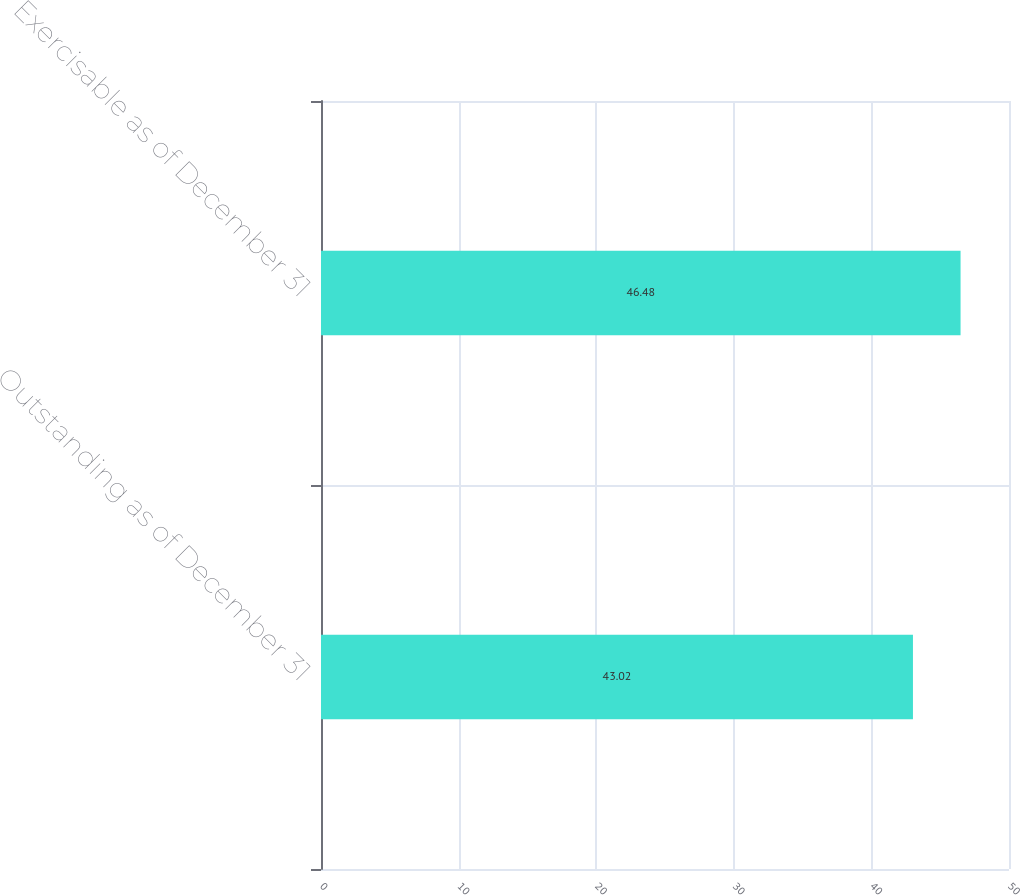Convert chart. <chart><loc_0><loc_0><loc_500><loc_500><bar_chart><fcel>Outstanding as of December 31<fcel>Exercisable as of December 31<nl><fcel>43.02<fcel>46.48<nl></chart> 